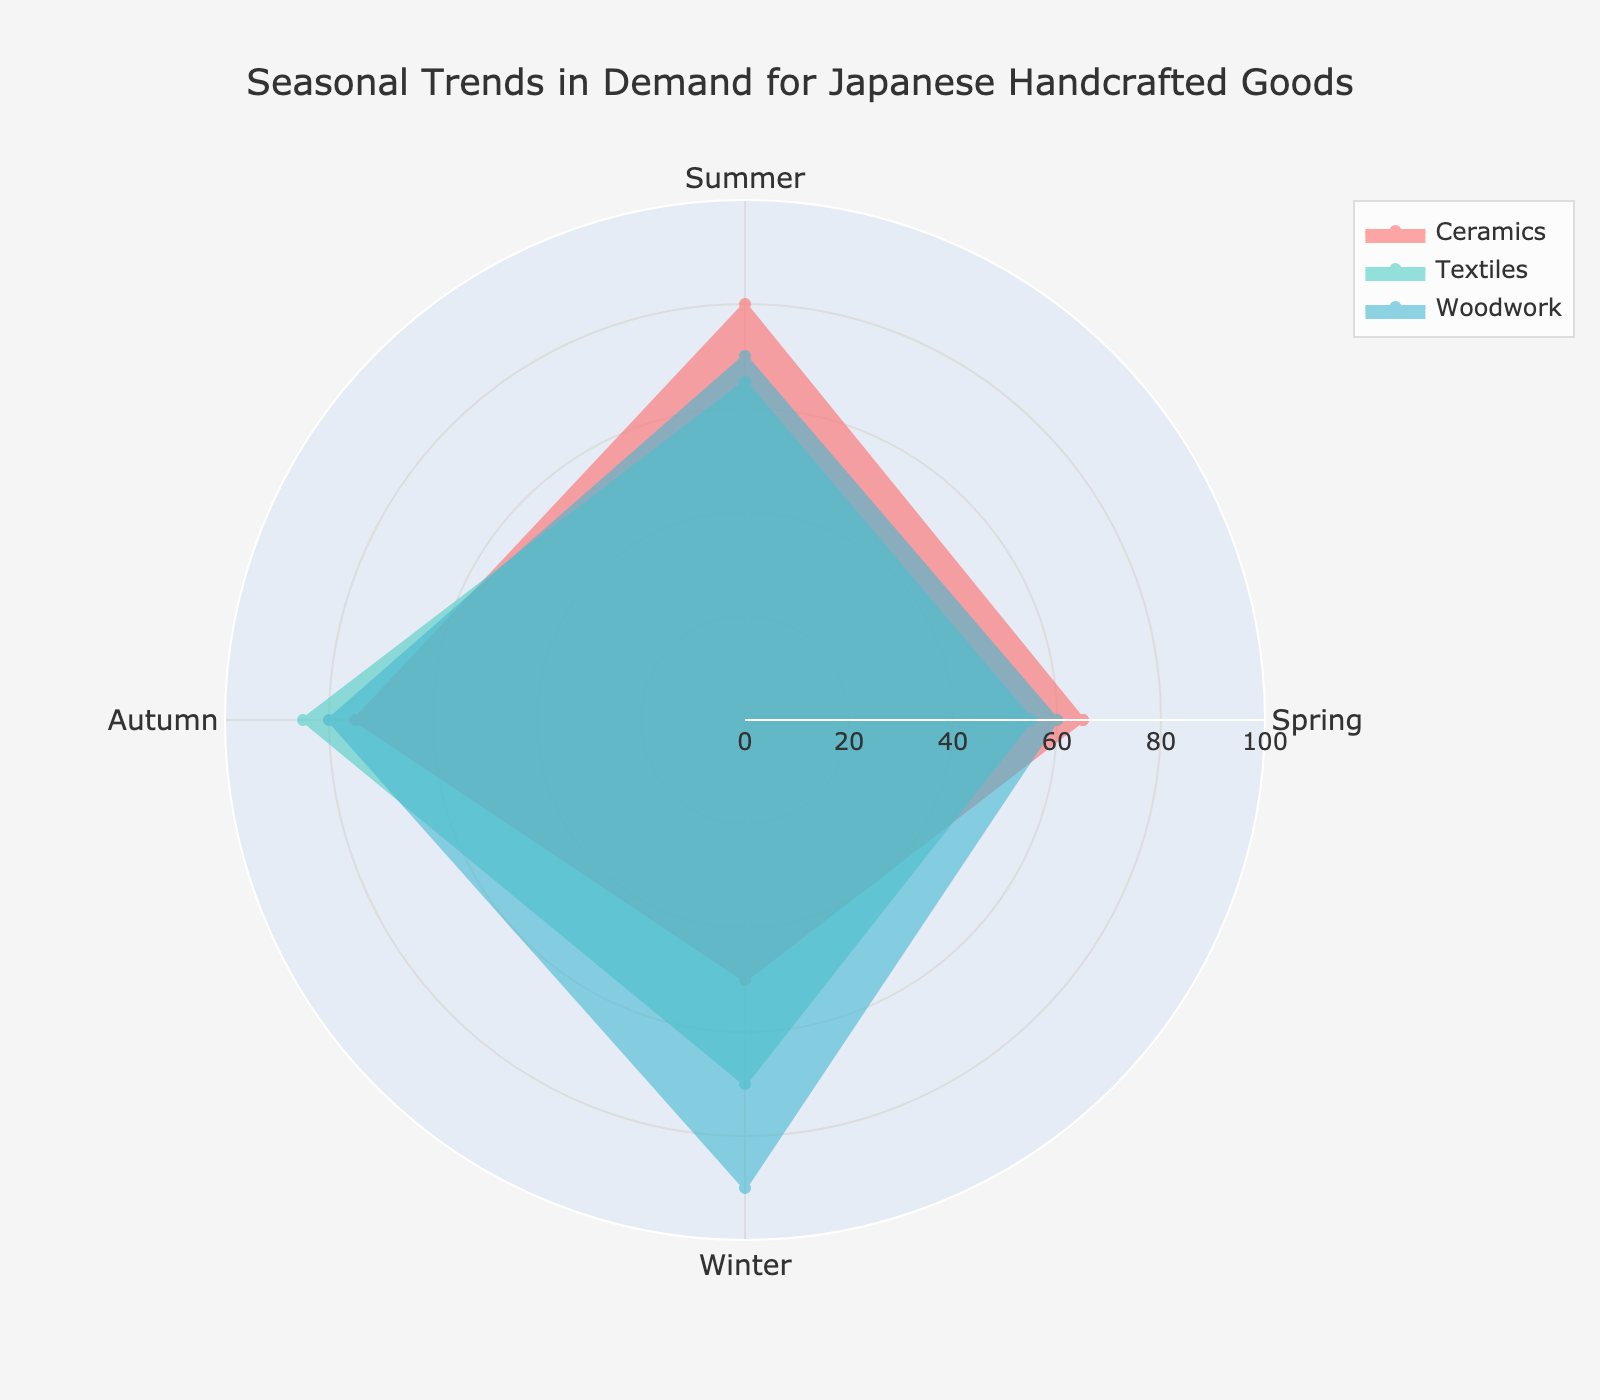What is the title of the radar chart? The title of a chart is usually displayed at the top and provides a summary of the chart's content. Here, the title reads "Seasonal Trends in Demand for Japanese Handcrafted Goods".
Answer: Seasonal Trends in Demand for Japanese Handcrafted Goods How many product categories are depicted in the chart? There are three major product categories shown in the legend and represented as different colored areas in the radar chart.
Answer: Three In which season does the demand for Ceramics peak? By observing the values for Ceramics across the seasons, the highest value (80) is in Summer, indicating the peak.
Answer: Summer Which product category has the highest demand in Winter? By comparing the values for Winter among the three categories, Woodwork has the highest value (90).
Answer: Woodwork What is the difference in demand for Textiles between Summer and Autumn? The values for Textiles are 65 in Summer and 85 in Autumn. The difference can be calculated as 85 - 65.
Answer: 20 Which product has the most consistent demand across all seasons? Consistency can be judged by looking at the range (difference between highest and lowest values). Ceramics has values ranging from 50 to 80, Textiles from 55 to 85, and Woodwork from 60 to 90. Ceramics has the smallest range (30).
Answer: Ceramics What is the average demand for Woodwork across all seasons? Adding up the values for Woodwork in all seasons (60 + 70 + 80 + 90) gives 300. Dividing by 4 yields the average.
Answer: 75 During which season is the gap between the highest and lowest demand the largest? By examining the maximum and minimum values for each season: Spring (65 - 55 = 10), Summer (80 - 65 = 15), Autumn (85 - 75 = 10), Winter (90 - 50 = 40), Winter has the largest gap.
Answer: Winter Which product category sees the maximum increase in demand from Spring to Summer? The increase in demand from Spring to Summer for each category is: Ceramics (80 - 65 = 15), Textiles (65 - 55 = 10), Woodwork (70 - 60 = 10). Ceramics has the maximum increase.
Answer: Ceramics 